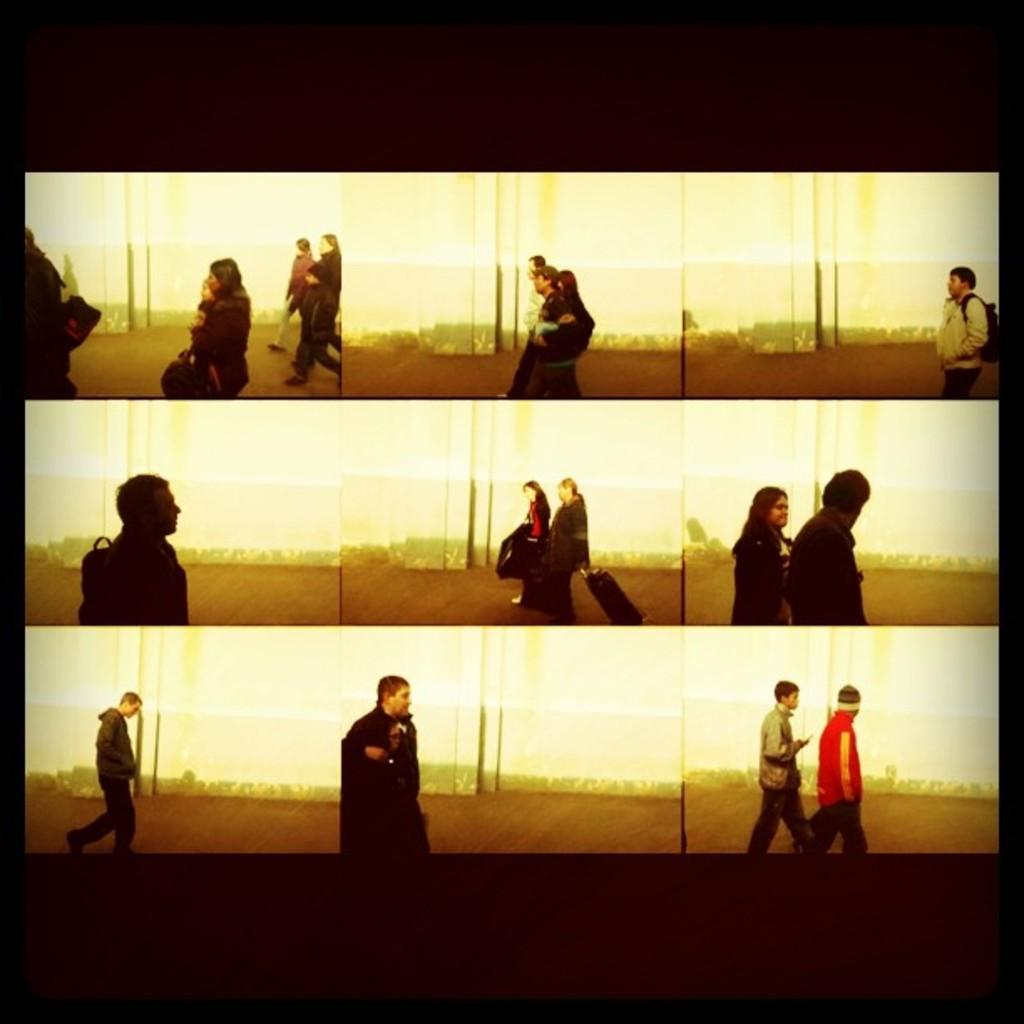What type of image is being described? The image is a collage. What can be observed in the collage? There are people walking in the image. What type of juice is being served in the image? There is no juice present in the image; it is a collage featuring people walking. What adjustments are being made by the people in the image? The provided facts do not mention any adjustments being made by the people in the image. 